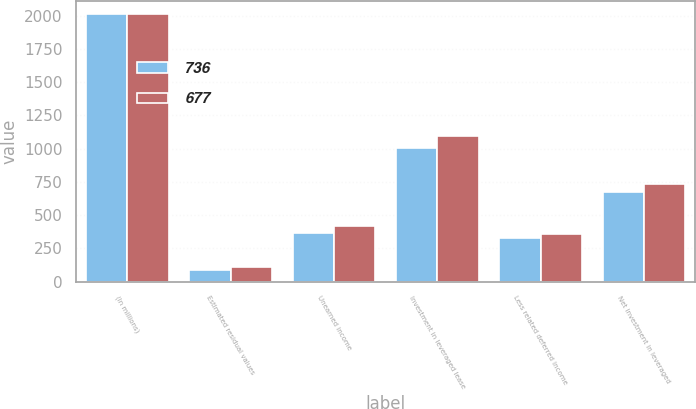<chart> <loc_0><loc_0><loc_500><loc_500><stacked_bar_chart><ecel><fcel>(In millions)<fcel>Estimated residual values<fcel>Unearned income<fcel>Investment in leveraged lease<fcel>Less related deferred income<fcel>Net investment in leveraged<nl><fcel>736<fcel>2014<fcel>89<fcel>370<fcel>1003<fcel>326<fcel>677<nl><fcel>677<fcel>2013<fcel>110<fcel>419<fcel>1095<fcel>359<fcel>736<nl></chart> 